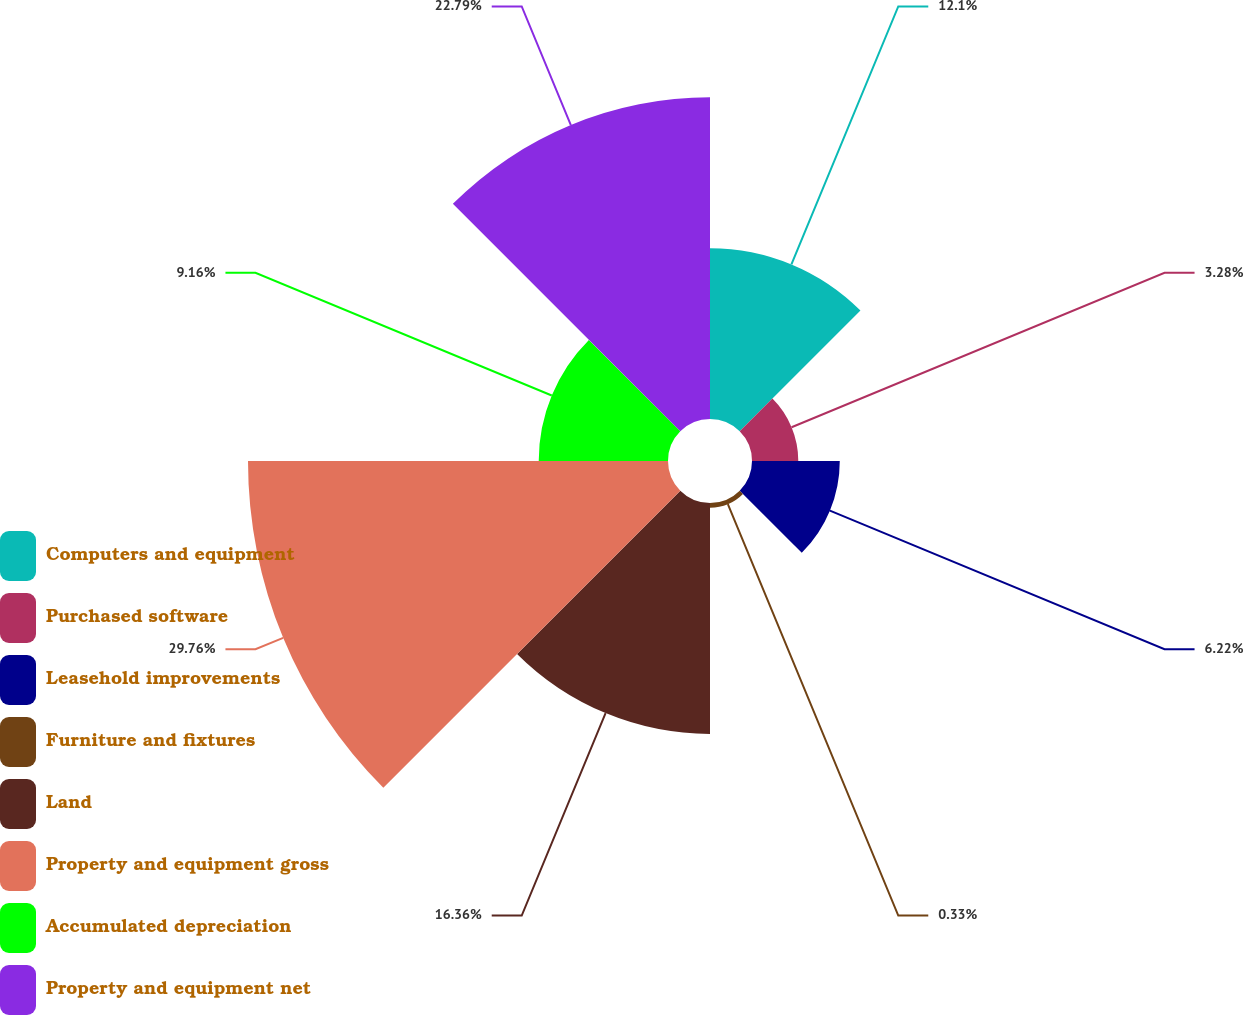Convert chart to OTSL. <chart><loc_0><loc_0><loc_500><loc_500><pie_chart><fcel>Computers and equipment<fcel>Purchased software<fcel>Leasehold improvements<fcel>Furniture and fixtures<fcel>Land<fcel>Property and equipment gross<fcel>Accumulated depreciation<fcel>Property and equipment net<nl><fcel>12.1%<fcel>3.28%<fcel>6.22%<fcel>0.33%<fcel>16.36%<fcel>29.76%<fcel>9.16%<fcel>22.79%<nl></chart> 